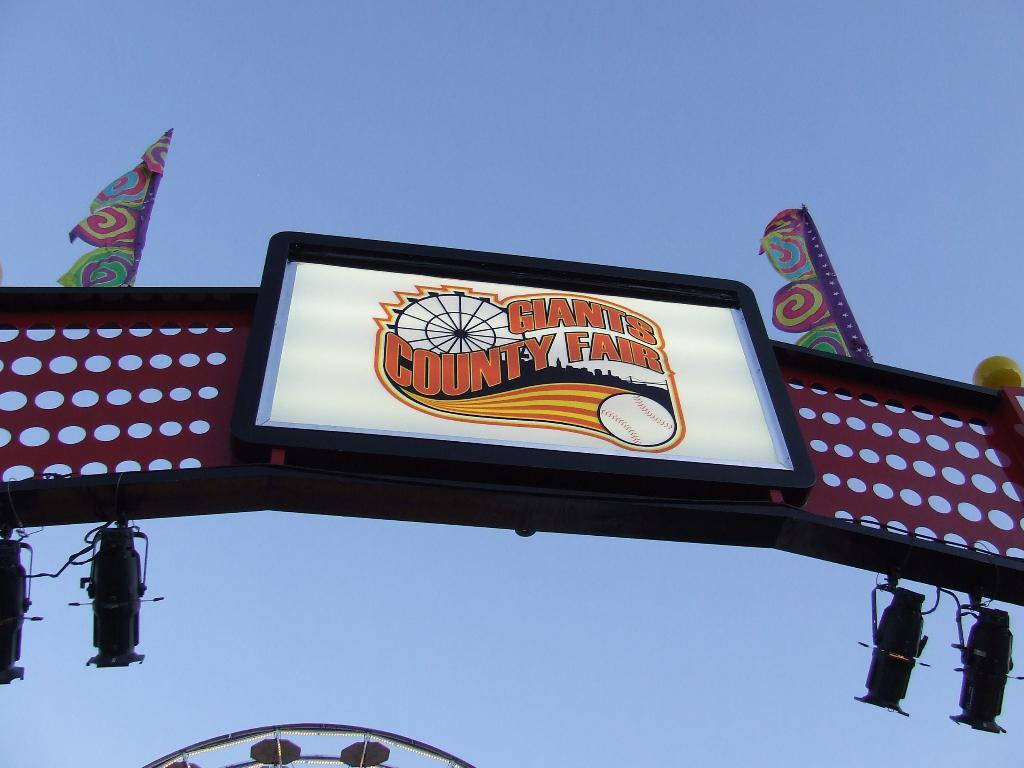What is on the arch in the image? There is a screen on an arch in the image. What else can be seen in the image besides the screen? There are flags and focus lights in the image. Can you describe the object in the image? There is an object in the image, but its description is not provided in the facts. What is visible in the background of the image? The sky is visible in the background of the image. How many sisters are holding combs in the image? There are no sisters or combs present in the image. What type of sponge is being used to clean the object in the image? There is no sponge or cleaning activity depicted in the image. 